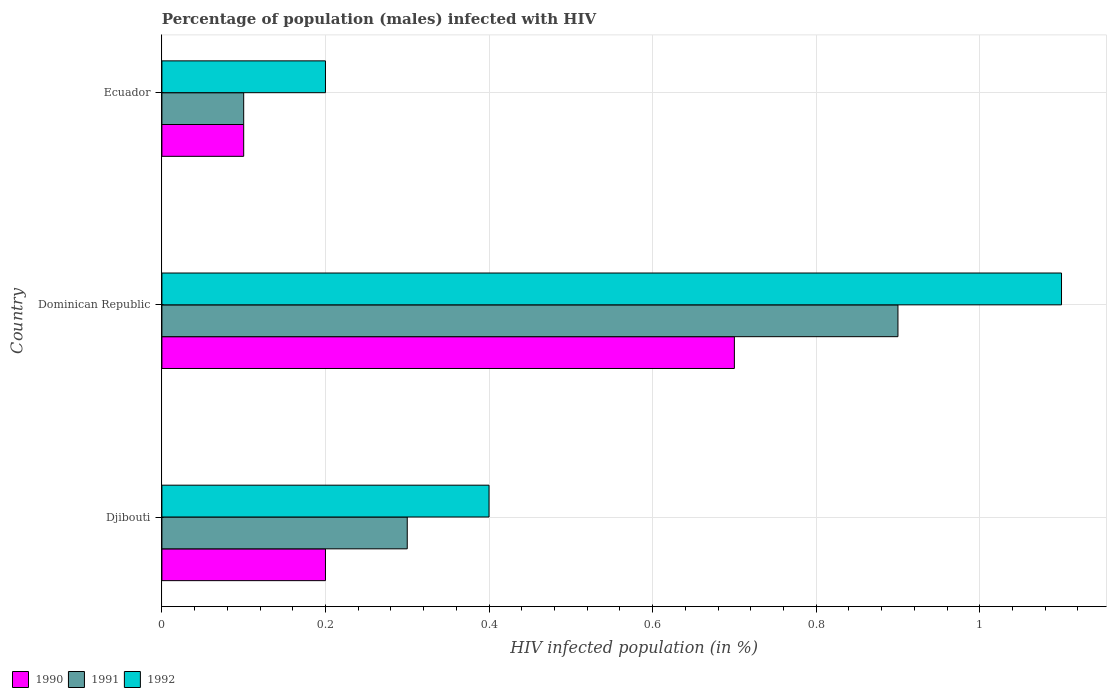How many groups of bars are there?
Your response must be concise. 3. Are the number of bars on each tick of the Y-axis equal?
Your response must be concise. Yes. How many bars are there on the 2nd tick from the bottom?
Your answer should be compact. 3. What is the label of the 2nd group of bars from the top?
Keep it short and to the point. Dominican Republic. In how many cases, is the number of bars for a given country not equal to the number of legend labels?
Your answer should be very brief. 0. What is the percentage of HIV infected male population in 1991 in Dominican Republic?
Offer a very short reply. 0.9. Across all countries, what is the maximum percentage of HIV infected male population in 1991?
Keep it short and to the point. 0.9. In which country was the percentage of HIV infected male population in 1990 maximum?
Your response must be concise. Dominican Republic. In which country was the percentage of HIV infected male population in 1990 minimum?
Your response must be concise. Ecuador. What is the difference between the percentage of HIV infected male population in 1991 in Dominican Republic and the percentage of HIV infected male population in 1990 in Ecuador?
Provide a short and direct response. 0.8. What is the average percentage of HIV infected male population in 1991 per country?
Keep it short and to the point. 0.43. What is the difference between the percentage of HIV infected male population in 1992 and percentage of HIV infected male population in 1990 in Djibouti?
Provide a short and direct response. 0.2. In how many countries, is the percentage of HIV infected male population in 1992 greater than 1 %?
Offer a very short reply. 1. What is the ratio of the percentage of HIV infected male population in 1992 in Dominican Republic to that in Ecuador?
Your answer should be compact. 5.5. Is the percentage of HIV infected male population in 1991 in Djibouti less than that in Dominican Republic?
Give a very brief answer. Yes. What is the difference between the highest and the second highest percentage of HIV infected male population in 1992?
Give a very brief answer. 0.7. What is the difference between the highest and the lowest percentage of HIV infected male population in 1991?
Ensure brevity in your answer.  0.8. Is the sum of the percentage of HIV infected male population in 1990 in Djibouti and Ecuador greater than the maximum percentage of HIV infected male population in 1992 across all countries?
Provide a short and direct response. No. What does the 3rd bar from the bottom in Djibouti represents?
Your answer should be compact. 1992. Are all the bars in the graph horizontal?
Your answer should be compact. Yes. What is the difference between two consecutive major ticks on the X-axis?
Make the answer very short. 0.2. What is the title of the graph?
Your answer should be very brief. Percentage of population (males) infected with HIV. What is the label or title of the X-axis?
Give a very brief answer. HIV infected population (in %). What is the HIV infected population (in %) of 1992 in Djibouti?
Your answer should be very brief. 0.4. What is the HIV infected population (in %) in 1990 in Dominican Republic?
Make the answer very short. 0.7. What is the HIV infected population (in %) of 1990 in Ecuador?
Your answer should be compact. 0.1. Across all countries, what is the minimum HIV infected population (in %) of 1990?
Your answer should be very brief. 0.1. What is the total HIV infected population (in %) in 1990 in the graph?
Offer a very short reply. 1. What is the total HIV infected population (in %) of 1991 in the graph?
Provide a succinct answer. 1.3. What is the total HIV infected population (in %) of 1992 in the graph?
Provide a short and direct response. 1.7. What is the difference between the HIV infected population (in %) of 1991 in Djibouti and that in Dominican Republic?
Make the answer very short. -0.6. What is the difference between the HIV infected population (in %) in 1992 in Djibouti and that in Dominican Republic?
Offer a very short reply. -0.7. What is the difference between the HIV infected population (in %) in 1991 in Djibouti and that in Ecuador?
Provide a short and direct response. 0.2. What is the difference between the HIV infected population (in %) of 1991 in Dominican Republic and that in Ecuador?
Provide a succinct answer. 0.8. What is the difference between the HIV infected population (in %) of 1990 in Djibouti and the HIV infected population (in %) of 1991 in Dominican Republic?
Offer a very short reply. -0.7. What is the difference between the HIV infected population (in %) in 1990 in Djibouti and the HIV infected population (in %) in 1992 in Dominican Republic?
Offer a very short reply. -0.9. What is the difference between the HIV infected population (in %) of 1990 in Djibouti and the HIV infected population (in %) of 1991 in Ecuador?
Your response must be concise. 0.1. What is the difference between the HIV infected population (in %) in 1990 in Dominican Republic and the HIV infected population (in %) in 1991 in Ecuador?
Your answer should be compact. 0.6. What is the difference between the HIV infected population (in %) in 1990 in Dominican Republic and the HIV infected population (in %) in 1992 in Ecuador?
Keep it short and to the point. 0.5. What is the difference between the HIV infected population (in %) of 1991 in Dominican Republic and the HIV infected population (in %) of 1992 in Ecuador?
Your answer should be compact. 0.7. What is the average HIV infected population (in %) of 1990 per country?
Ensure brevity in your answer.  0.33. What is the average HIV infected population (in %) of 1991 per country?
Give a very brief answer. 0.43. What is the average HIV infected population (in %) of 1992 per country?
Keep it short and to the point. 0.57. What is the difference between the HIV infected population (in %) of 1990 and HIV infected population (in %) of 1991 in Djibouti?
Your response must be concise. -0.1. What is the difference between the HIV infected population (in %) in 1990 and HIV infected population (in %) in 1992 in Dominican Republic?
Your answer should be very brief. -0.4. What is the difference between the HIV infected population (in %) in 1991 and HIV infected population (in %) in 1992 in Ecuador?
Your response must be concise. -0.1. What is the ratio of the HIV infected population (in %) in 1990 in Djibouti to that in Dominican Republic?
Offer a very short reply. 0.29. What is the ratio of the HIV infected population (in %) of 1991 in Djibouti to that in Dominican Republic?
Give a very brief answer. 0.33. What is the ratio of the HIV infected population (in %) of 1992 in Djibouti to that in Dominican Republic?
Offer a very short reply. 0.36. What is the ratio of the HIV infected population (in %) of 1990 in Djibouti to that in Ecuador?
Give a very brief answer. 2. What is the ratio of the HIV infected population (in %) of 1991 in Djibouti to that in Ecuador?
Keep it short and to the point. 3. What is the ratio of the HIV infected population (in %) in 1992 in Djibouti to that in Ecuador?
Keep it short and to the point. 2. What is the ratio of the HIV infected population (in %) in 1990 in Dominican Republic to that in Ecuador?
Offer a terse response. 7. What is the ratio of the HIV infected population (in %) in 1992 in Dominican Republic to that in Ecuador?
Provide a succinct answer. 5.5. What is the difference between the highest and the second highest HIV infected population (in %) of 1990?
Provide a short and direct response. 0.5. What is the difference between the highest and the second highest HIV infected population (in %) of 1992?
Your answer should be compact. 0.7. What is the difference between the highest and the lowest HIV infected population (in %) of 1990?
Ensure brevity in your answer.  0.6. 